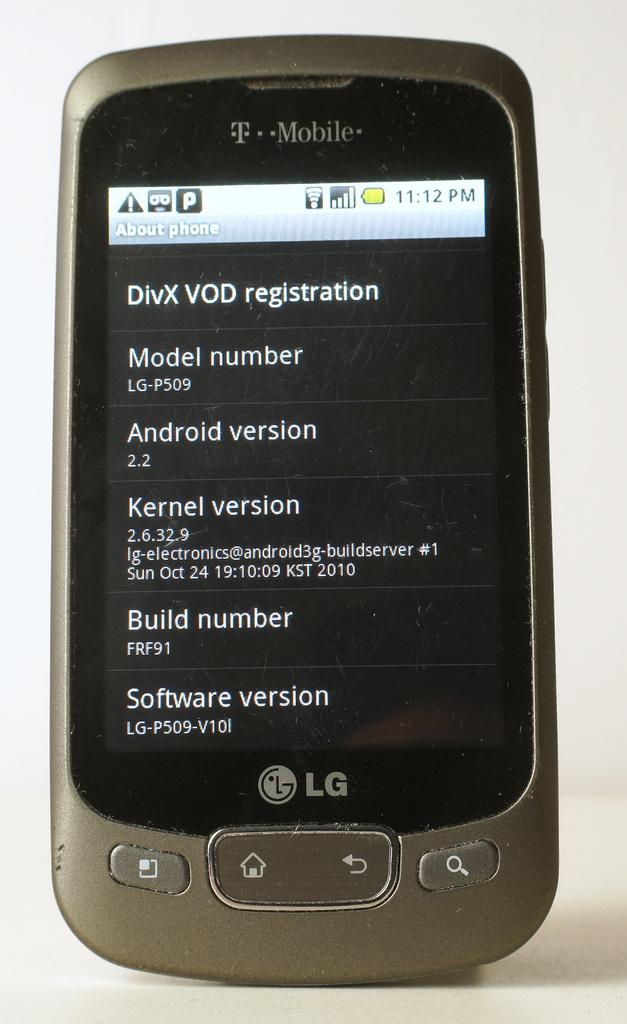What company manufactured the phone?
Your answer should be very brief. Lg. This is drinks?
Make the answer very short. Answering does not require reading text in the image. 